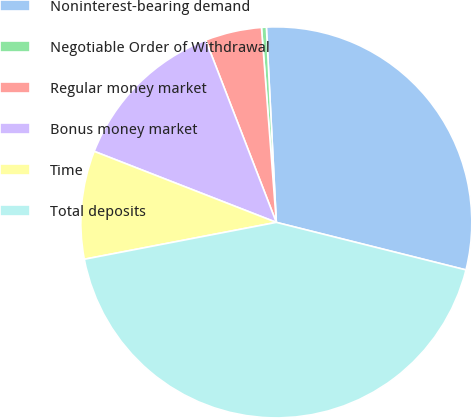<chart> <loc_0><loc_0><loc_500><loc_500><pie_chart><fcel>Noninterest-bearing demand<fcel>Negotiable Order of Withdrawal<fcel>Regular money market<fcel>Bonus money market<fcel>Time<fcel>Total deposits<nl><fcel>29.72%<fcel>0.4%<fcel>4.67%<fcel>13.2%<fcel>8.94%<fcel>43.07%<nl></chart> 